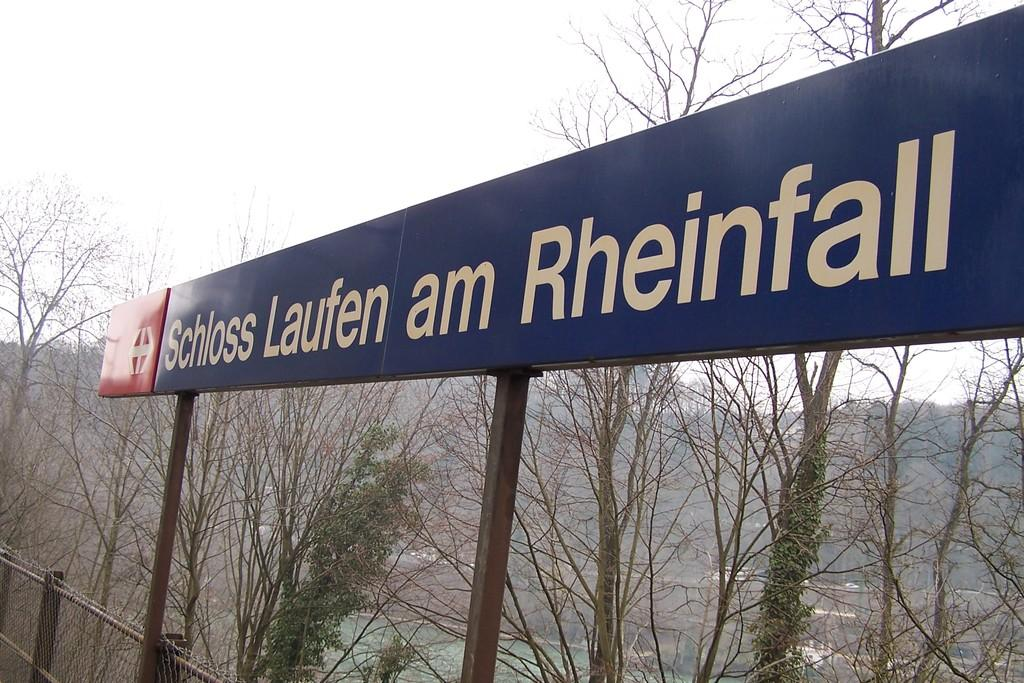What is located at the front of the image? There is a board in the front of the image. What can be found on the board? There is text on the board. What type of natural environment is visible in the background of the image? There are trees and water visible in the background of the image. What is visible at the top of the image? The sky is visible at the top of the image. What type of button is being used in the historical fight depicted in the image? There is no button or historical fight present in the image; it features a board with text and a natural background. 